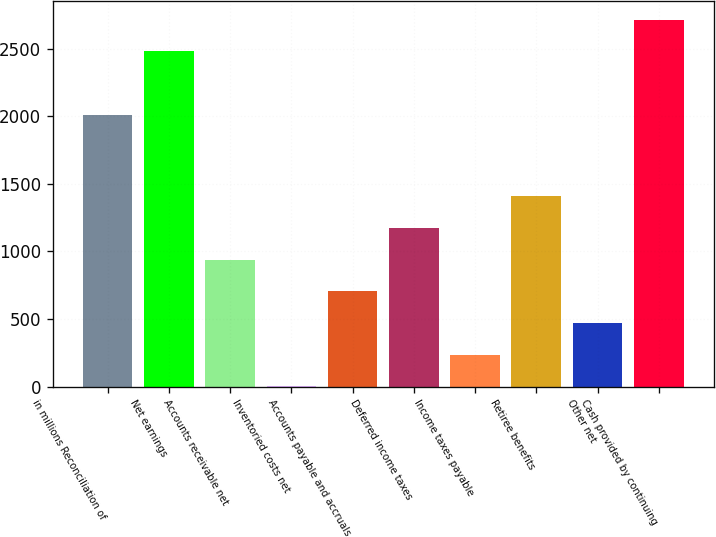Convert chart. <chart><loc_0><loc_0><loc_500><loc_500><bar_chart><fcel>in millions Reconciliation of<fcel>Net earnings<fcel>Accounts receivable net<fcel>Inventoried costs net<fcel>Accounts payable and accruals<fcel>Deferred income taxes<fcel>Income taxes payable<fcel>Retiree benefits<fcel>Other net<fcel>Cash provided by continuing<nl><fcel>2011<fcel>2480<fcel>940<fcel>2<fcel>705.5<fcel>1174.5<fcel>236.5<fcel>1409<fcel>471<fcel>2714.5<nl></chart> 